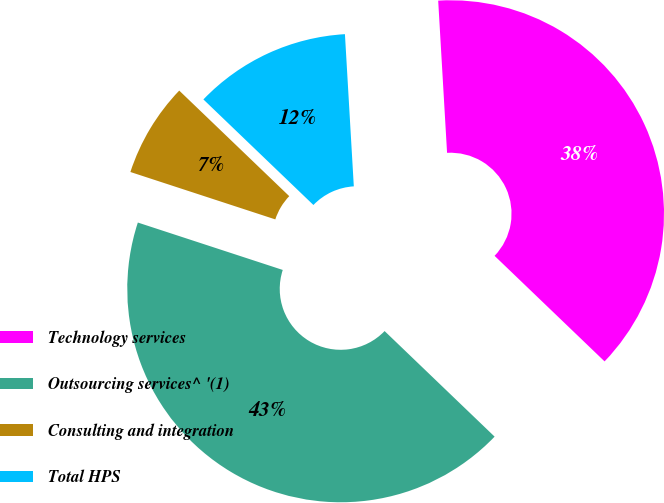Convert chart. <chart><loc_0><loc_0><loc_500><loc_500><pie_chart><fcel>Technology services<fcel>Outsourcing services^ '(1)<fcel>Consulting and integration<fcel>Total HPS<nl><fcel>38.1%<fcel>42.86%<fcel>7.14%<fcel>11.9%<nl></chart> 